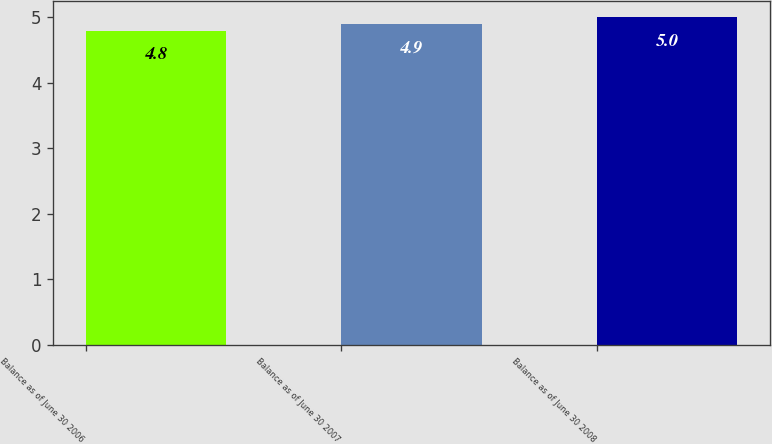Convert chart. <chart><loc_0><loc_0><loc_500><loc_500><bar_chart><fcel>Balance as of June 30 2006<fcel>Balance as of June 30 2007<fcel>Balance as of June 30 2008<nl><fcel>4.8<fcel>4.9<fcel>5<nl></chart> 